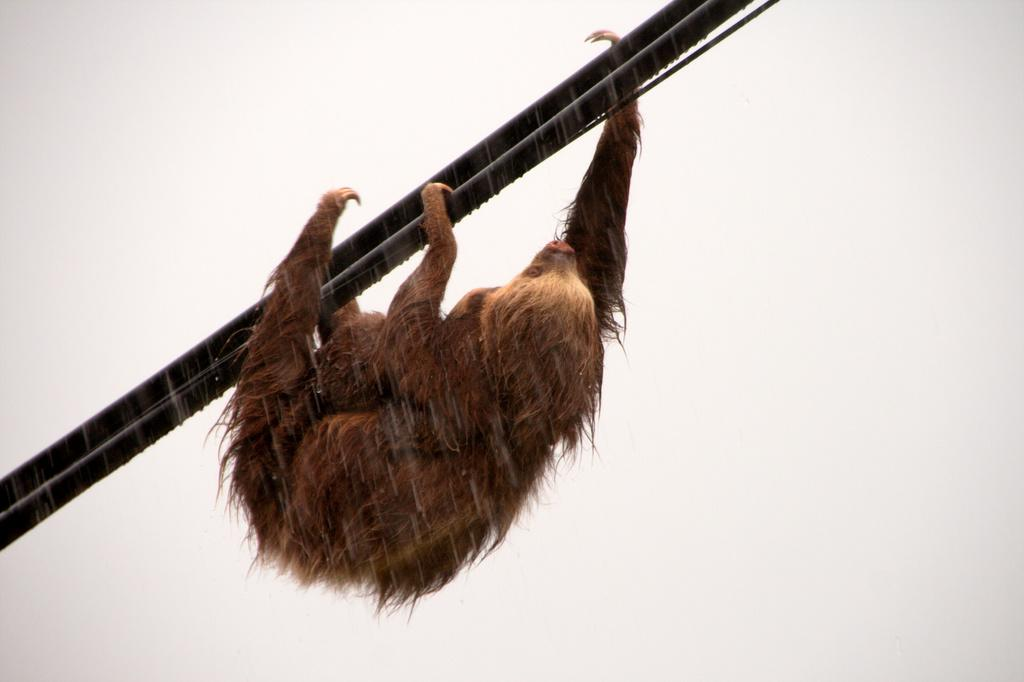What type of animal is in the image? There is a sloth animal in the image. What is the sloth animal doing in the image? The sloth animal is climbing a pole. What is the condition of the sky in the image? The sky is clear in the image. What rule is the sloth animal following while climbing the pole in the image? There is no specific rule mentioned or implied in the image regarding the sloth animal's actions while climbing the pole. What is the sloth animal's stomach doing while climbing the pole in the image? The image does not provide information about the sloth animal's stomach or its actions, as it focuses on the animal's climbing activity. 